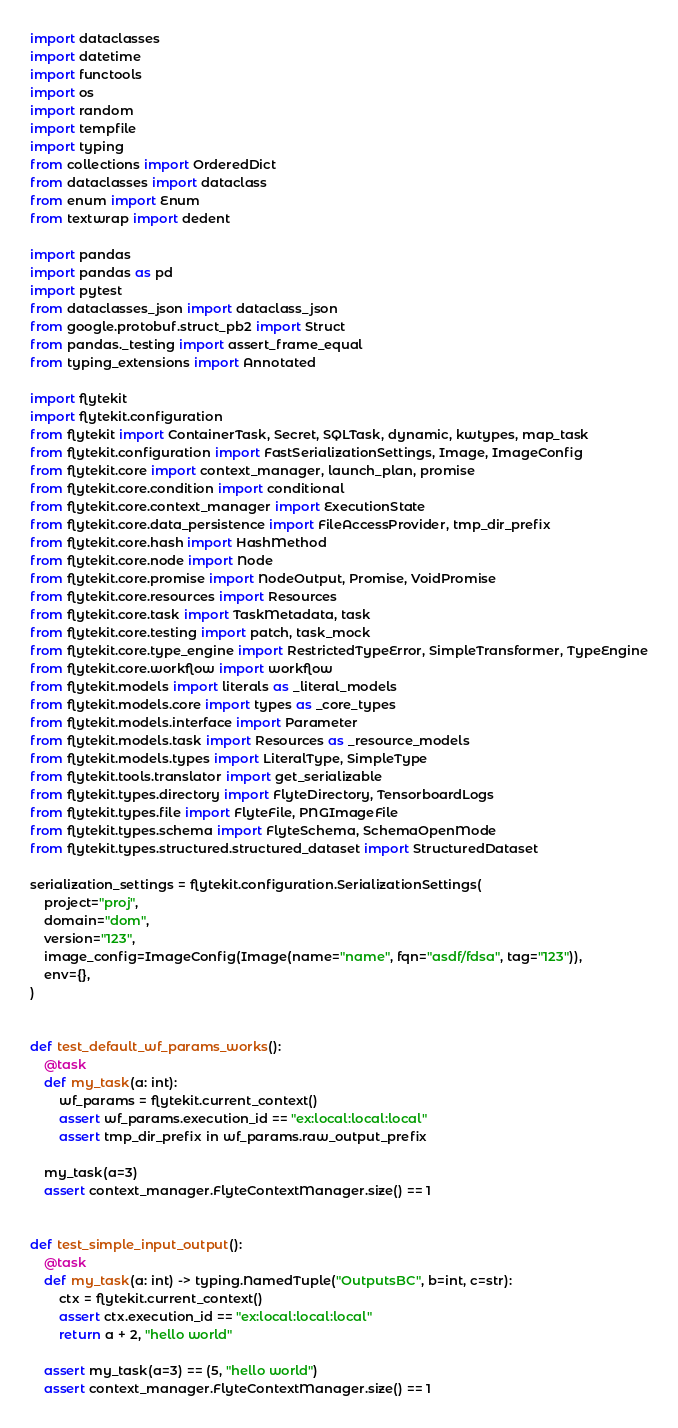<code> <loc_0><loc_0><loc_500><loc_500><_Python_>import dataclasses
import datetime
import functools
import os
import random
import tempfile
import typing
from collections import OrderedDict
from dataclasses import dataclass
from enum import Enum
from textwrap import dedent

import pandas
import pandas as pd
import pytest
from dataclasses_json import dataclass_json
from google.protobuf.struct_pb2 import Struct
from pandas._testing import assert_frame_equal
from typing_extensions import Annotated

import flytekit
import flytekit.configuration
from flytekit import ContainerTask, Secret, SQLTask, dynamic, kwtypes, map_task
from flytekit.configuration import FastSerializationSettings, Image, ImageConfig
from flytekit.core import context_manager, launch_plan, promise
from flytekit.core.condition import conditional
from flytekit.core.context_manager import ExecutionState
from flytekit.core.data_persistence import FileAccessProvider, tmp_dir_prefix
from flytekit.core.hash import HashMethod
from flytekit.core.node import Node
from flytekit.core.promise import NodeOutput, Promise, VoidPromise
from flytekit.core.resources import Resources
from flytekit.core.task import TaskMetadata, task
from flytekit.core.testing import patch, task_mock
from flytekit.core.type_engine import RestrictedTypeError, SimpleTransformer, TypeEngine
from flytekit.core.workflow import workflow
from flytekit.models import literals as _literal_models
from flytekit.models.core import types as _core_types
from flytekit.models.interface import Parameter
from flytekit.models.task import Resources as _resource_models
from flytekit.models.types import LiteralType, SimpleType
from flytekit.tools.translator import get_serializable
from flytekit.types.directory import FlyteDirectory, TensorboardLogs
from flytekit.types.file import FlyteFile, PNGImageFile
from flytekit.types.schema import FlyteSchema, SchemaOpenMode
from flytekit.types.structured.structured_dataset import StructuredDataset

serialization_settings = flytekit.configuration.SerializationSettings(
    project="proj",
    domain="dom",
    version="123",
    image_config=ImageConfig(Image(name="name", fqn="asdf/fdsa", tag="123")),
    env={},
)


def test_default_wf_params_works():
    @task
    def my_task(a: int):
        wf_params = flytekit.current_context()
        assert wf_params.execution_id == "ex:local:local:local"
        assert tmp_dir_prefix in wf_params.raw_output_prefix

    my_task(a=3)
    assert context_manager.FlyteContextManager.size() == 1


def test_simple_input_output():
    @task
    def my_task(a: int) -> typing.NamedTuple("OutputsBC", b=int, c=str):
        ctx = flytekit.current_context()
        assert ctx.execution_id == "ex:local:local:local"
        return a + 2, "hello world"

    assert my_task(a=3) == (5, "hello world")
    assert context_manager.FlyteContextManager.size() == 1

</code> 